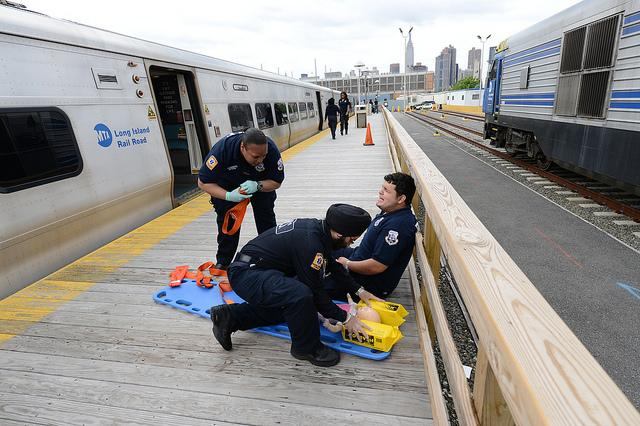Which major US city does this train line service? new york 